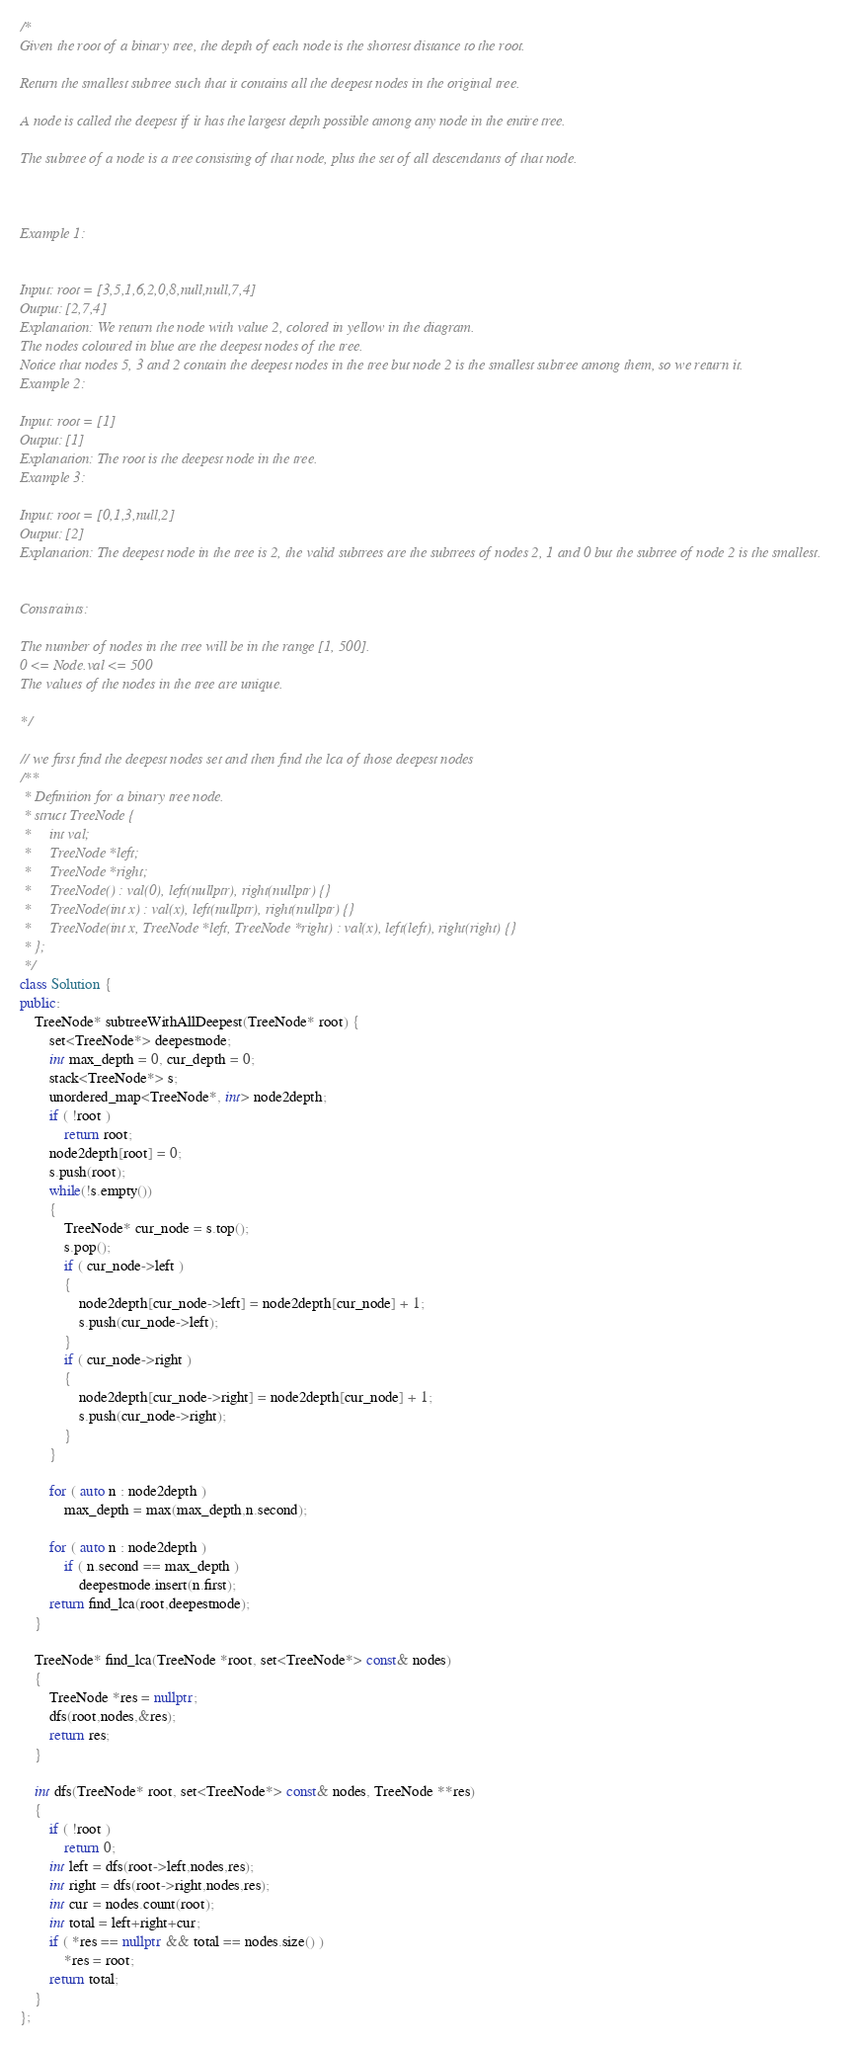Convert code to text. <code><loc_0><loc_0><loc_500><loc_500><_C++_>/*
Given the root of a binary tree, the depth of each node is the shortest distance to the root.

Return the smallest subtree such that it contains all the deepest nodes in the original tree.

A node is called the deepest if it has the largest depth possible among any node in the entire tree.

The subtree of a node is a tree consisting of that node, plus the set of all descendants of that node.

 

Example 1:


Input: root = [3,5,1,6,2,0,8,null,null,7,4]
Output: [2,7,4]
Explanation: We return the node with value 2, colored in yellow in the diagram.
The nodes coloured in blue are the deepest nodes of the tree.
Notice that nodes 5, 3 and 2 contain the deepest nodes in the tree but node 2 is the smallest subtree among them, so we return it.
Example 2:

Input: root = [1]
Output: [1]
Explanation: The root is the deepest node in the tree.
Example 3:

Input: root = [0,1,3,null,2]
Output: [2]
Explanation: The deepest node in the tree is 2, the valid subtrees are the subtrees of nodes 2, 1 and 0 but the subtree of node 2 is the smallest.
 

Constraints:

The number of nodes in the tree will be in the range [1, 500].
0 <= Node.val <= 500
The values of the nodes in the tree are unique.

*/

// we first find the deepest nodes set and then find the lca of those deepest nodes 
/**
 * Definition for a binary tree node.
 * struct TreeNode {
 *     int val;
 *     TreeNode *left;
 *     TreeNode *right;
 *     TreeNode() : val(0), left(nullptr), right(nullptr) {}
 *     TreeNode(int x) : val(x), left(nullptr), right(nullptr) {}
 *     TreeNode(int x, TreeNode *left, TreeNode *right) : val(x), left(left), right(right) {}
 * };
 */
class Solution {
public:
    TreeNode* subtreeWithAllDeepest(TreeNode* root) {
        set<TreeNode*> deepestnode;
        int max_depth = 0, cur_depth = 0;
        stack<TreeNode*> s;
        unordered_map<TreeNode*, int> node2depth;
        if ( !root )
            return root;
        node2depth[root] = 0;
        s.push(root);
        while(!s.empty())
        {
            TreeNode* cur_node = s.top();
            s.pop();
            if ( cur_node->left )
            {
                node2depth[cur_node->left] = node2depth[cur_node] + 1;
                s.push(cur_node->left);
            }
            if ( cur_node->right )
            {
                node2depth[cur_node->right] = node2depth[cur_node] + 1;
                s.push(cur_node->right);
            }
        }
        
        for ( auto n : node2depth )
            max_depth = max(max_depth,n.second);
        
        for ( auto n : node2depth )
            if ( n.second == max_depth )
                deepestnode.insert(n.first);
        return find_lca(root,deepestnode);
    }
    
    TreeNode* find_lca(TreeNode *root, set<TreeNode*> const& nodes)
    {
        TreeNode *res = nullptr;
        dfs(root,nodes,&res);
        return res;
    }
    
    int dfs(TreeNode* root, set<TreeNode*> const& nodes, TreeNode **res)
    {
        if ( !root )
            return 0;
        int left = dfs(root->left,nodes,res);
        int right = dfs(root->right,nodes,res);
        int cur = nodes.count(root);
        int total = left+right+cur;
        if ( *res == nullptr && total == nodes.size() )
            *res = root;
        return total;
    }
};</code> 